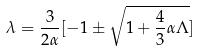Convert formula to latex. <formula><loc_0><loc_0><loc_500><loc_500>\lambda = \frac { 3 } { 2 \alpha } [ - 1 \pm \sqrt { 1 + \frac { 4 } { 3 } \alpha \Lambda } ]</formula> 